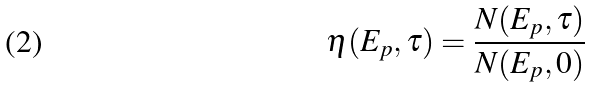<formula> <loc_0><loc_0><loc_500><loc_500>\eta ( E _ { p } , \tau ) = \frac { N ( E _ { p } , \tau ) } { N ( E _ { p } , 0 ) }</formula> 